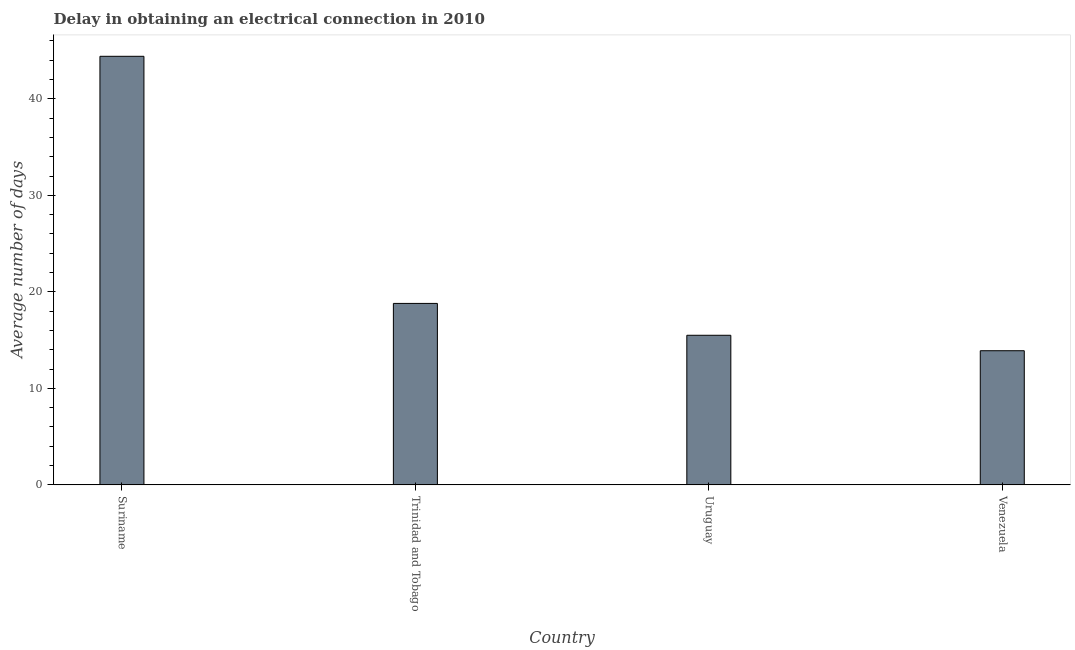Does the graph contain any zero values?
Offer a very short reply. No. What is the title of the graph?
Ensure brevity in your answer.  Delay in obtaining an electrical connection in 2010. What is the label or title of the Y-axis?
Offer a very short reply. Average number of days. Across all countries, what is the maximum dalay in electrical connection?
Offer a terse response. 44.4. In which country was the dalay in electrical connection maximum?
Offer a very short reply. Suriname. In which country was the dalay in electrical connection minimum?
Your answer should be compact. Venezuela. What is the sum of the dalay in electrical connection?
Ensure brevity in your answer.  92.6. What is the difference between the dalay in electrical connection in Suriname and Venezuela?
Your response must be concise. 30.5. What is the average dalay in electrical connection per country?
Your response must be concise. 23.15. What is the median dalay in electrical connection?
Provide a short and direct response. 17.15. What is the ratio of the dalay in electrical connection in Trinidad and Tobago to that in Uruguay?
Keep it short and to the point. 1.21. Is the dalay in electrical connection in Suriname less than that in Uruguay?
Offer a very short reply. No. What is the difference between the highest and the second highest dalay in electrical connection?
Ensure brevity in your answer.  25.6. What is the difference between the highest and the lowest dalay in electrical connection?
Give a very brief answer. 30.5. How many countries are there in the graph?
Offer a terse response. 4. Are the values on the major ticks of Y-axis written in scientific E-notation?
Make the answer very short. No. What is the Average number of days in Suriname?
Provide a succinct answer. 44.4. What is the Average number of days in Trinidad and Tobago?
Give a very brief answer. 18.8. What is the Average number of days in Uruguay?
Keep it short and to the point. 15.5. What is the Average number of days in Venezuela?
Give a very brief answer. 13.9. What is the difference between the Average number of days in Suriname and Trinidad and Tobago?
Make the answer very short. 25.6. What is the difference between the Average number of days in Suriname and Uruguay?
Give a very brief answer. 28.9. What is the difference between the Average number of days in Suriname and Venezuela?
Provide a short and direct response. 30.5. What is the difference between the Average number of days in Trinidad and Tobago and Uruguay?
Ensure brevity in your answer.  3.3. What is the ratio of the Average number of days in Suriname to that in Trinidad and Tobago?
Keep it short and to the point. 2.36. What is the ratio of the Average number of days in Suriname to that in Uruguay?
Provide a succinct answer. 2.87. What is the ratio of the Average number of days in Suriname to that in Venezuela?
Your response must be concise. 3.19. What is the ratio of the Average number of days in Trinidad and Tobago to that in Uruguay?
Your answer should be very brief. 1.21. What is the ratio of the Average number of days in Trinidad and Tobago to that in Venezuela?
Offer a terse response. 1.35. What is the ratio of the Average number of days in Uruguay to that in Venezuela?
Your answer should be very brief. 1.11. 